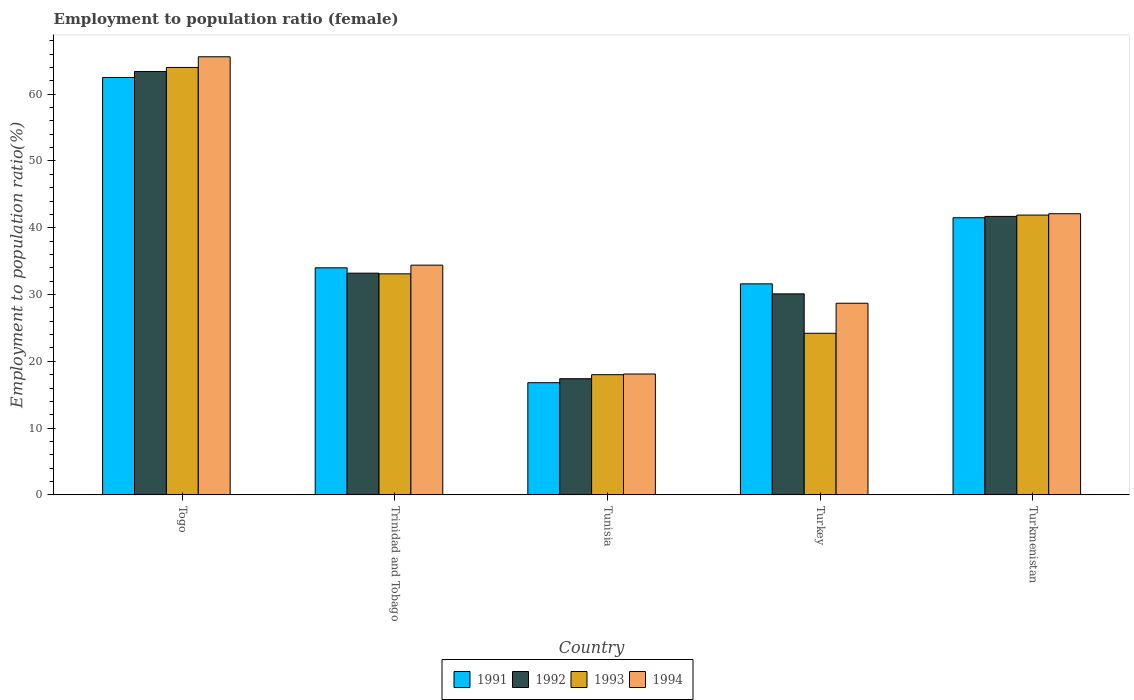Are the number of bars on each tick of the X-axis equal?
Offer a terse response. Yes. What is the label of the 1st group of bars from the left?
Provide a succinct answer. Togo. In how many cases, is the number of bars for a given country not equal to the number of legend labels?
Your response must be concise. 0. What is the employment to population ratio in 1993 in Tunisia?
Your answer should be very brief. 18. Across all countries, what is the maximum employment to population ratio in 1993?
Keep it short and to the point. 64. Across all countries, what is the minimum employment to population ratio in 1994?
Offer a very short reply. 18.1. In which country was the employment to population ratio in 1991 maximum?
Offer a terse response. Togo. In which country was the employment to population ratio in 1992 minimum?
Your answer should be compact. Tunisia. What is the total employment to population ratio in 1993 in the graph?
Keep it short and to the point. 181.2. What is the difference between the employment to population ratio in 1993 in Turkey and that in Turkmenistan?
Keep it short and to the point. -17.7. What is the difference between the employment to population ratio in 1992 in Trinidad and Tobago and the employment to population ratio in 1994 in Togo?
Your answer should be very brief. -32.4. What is the average employment to population ratio in 1992 per country?
Provide a succinct answer. 37.16. What is the difference between the employment to population ratio of/in 1994 and employment to population ratio of/in 1991 in Turkey?
Keep it short and to the point. -2.9. In how many countries, is the employment to population ratio in 1992 greater than 28 %?
Ensure brevity in your answer.  4. What is the ratio of the employment to population ratio in 1994 in Tunisia to that in Turkey?
Offer a terse response. 0.63. Is the difference between the employment to population ratio in 1994 in Trinidad and Tobago and Tunisia greater than the difference between the employment to population ratio in 1991 in Trinidad and Tobago and Tunisia?
Your response must be concise. No. What is the difference between the highest and the second highest employment to population ratio in 1994?
Make the answer very short. 23.5. What is the difference between the highest and the lowest employment to population ratio in 1991?
Provide a succinct answer. 45.7. Is it the case that in every country, the sum of the employment to population ratio in 1992 and employment to population ratio in 1994 is greater than the sum of employment to population ratio in 1991 and employment to population ratio in 1993?
Ensure brevity in your answer.  No. What does the 1st bar from the left in Trinidad and Tobago represents?
Provide a short and direct response. 1991. What does the 4th bar from the right in Togo represents?
Keep it short and to the point. 1991. Are all the bars in the graph horizontal?
Make the answer very short. No. What is the difference between two consecutive major ticks on the Y-axis?
Offer a very short reply. 10. Does the graph contain any zero values?
Your response must be concise. No. How many legend labels are there?
Offer a terse response. 4. How are the legend labels stacked?
Provide a short and direct response. Horizontal. What is the title of the graph?
Offer a very short reply. Employment to population ratio (female). What is the label or title of the X-axis?
Your answer should be compact. Country. What is the label or title of the Y-axis?
Your answer should be very brief. Employment to population ratio(%). What is the Employment to population ratio(%) in 1991 in Togo?
Provide a succinct answer. 62.5. What is the Employment to population ratio(%) in 1992 in Togo?
Offer a very short reply. 63.4. What is the Employment to population ratio(%) of 1994 in Togo?
Keep it short and to the point. 65.6. What is the Employment to population ratio(%) of 1991 in Trinidad and Tobago?
Provide a short and direct response. 34. What is the Employment to population ratio(%) of 1992 in Trinidad and Tobago?
Your answer should be compact. 33.2. What is the Employment to population ratio(%) in 1993 in Trinidad and Tobago?
Your answer should be compact. 33.1. What is the Employment to population ratio(%) in 1994 in Trinidad and Tobago?
Give a very brief answer. 34.4. What is the Employment to population ratio(%) in 1991 in Tunisia?
Provide a succinct answer. 16.8. What is the Employment to population ratio(%) of 1992 in Tunisia?
Keep it short and to the point. 17.4. What is the Employment to population ratio(%) of 1993 in Tunisia?
Provide a succinct answer. 18. What is the Employment to population ratio(%) in 1994 in Tunisia?
Give a very brief answer. 18.1. What is the Employment to population ratio(%) in 1991 in Turkey?
Provide a short and direct response. 31.6. What is the Employment to population ratio(%) of 1992 in Turkey?
Offer a terse response. 30.1. What is the Employment to population ratio(%) in 1993 in Turkey?
Ensure brevity in your answer.  24.2. What is the Employment to population ratio(%) of 1994 in Turkey?
Offer a very short reply. 28.7. What is the Employment to population ratio(%) in 1991 in Turkmenistan?
Ensure brevity in your answer.  41.5. What is the Employment to population ratio(%) in 1992 in Turkmenistan?
Provide a short and direct response. 41.7. What is the Employment to population ratio(%) of 1993 in Turkmenistan?
Offer a very short reply. 41.9. What is the Employment to population ratio(%) of 1994 in Turkmenistan?
Keep it short and to the point. 42.1. Across all countries, what is the maximum Employment to population ratio(%) in 1991?
Your response must be concise. 62.5. Across all countries, what is the maximum Employment to population ratio(%) of 1992?
Your answer should be very brief. 63.4. Across all countries, what is the maximum Employment to population ratio(%) of 1993?
Make the answer very short. 64. Across all countries, what is the maximum Employment to population ratio(%) of 1994?
Provide a succinct answer. 65.6. Across all countries, what is the minimum Employment to population ratio(%) of 1991?
Give a very brief answer. 16.8. Across all countries, what is the minimum Employment to population ratio(%) in 1992?
Offer a terse response. 17.4. Across all countries, what is the minimum Employment to population ratio(%) of 1993?
Make the answer very short. 18. Across all countries, what is the minimum Employment to population ratio(%) in 1994?
Your response must be concise. 18.1. What is the total Employment to population ratio(%) of 1991 in the graph?
Offer a terse response. 186.4. What is the total Employment to population ratio(%) in 1992 in the graph?
Your answer should be very brief. 185.8. What is the total Employment to population ratio(%) of 1993 in the graph?
Make the answer very short. 181.2. What is the total Employment to population ratio(%) in 1994 in the graph?
Offer a very short reply. 188.9. What is the difference between the Employment to population ratio(%) of 1992 in Togo and that in Trinidad and Tobago?
Ensure brevity in your answer.  30.2. What is the difference between the Employment to population ratio(%) of 1993 in Togo and that in Trinidad and Tobago?
Make the answer very short. 30.9. What is the difference between the Employment to population ratio(%) in 1994 in Togo and that in Trinidad and Tobago?
Keep it short and to the point. 31.2. What is the difference between the Employment to population ratio(%) of 1991 in Togo and that in Tunisia?
Keep it short and to the point. 45.7. What is the difference between the Employment to population ratio(%) of 1994 in Togo and that in Tunisia?
Offer a very short reply. 47.5. What is the difference between the Employment to population ratio(%) in 1991 in Togo and that in Turkey?
Keep it short and to the point. 30.9. What is the difference between the Employment to population ratio(%) of 1992 in Togo and that in Turkey?
Your answer should be very brief. 33.3. What is the difference between the Employment to population ratio(%) of 1993 in Togo and that in Turkey?
Make the answer very short. 39.8. What is the difference between the Employment to population ratio(%) of 1994 in Togo and that in Turkey?
Make the answer very short. 36.9. What is the difference between the Employment to population ratio(%) in 1992 in Togo and that in Turkmenistan?
Provide a short and direct response. 21.7. What is the difference between the Employment to population ratio(%) in 1993 in Togo and that in Turkmenistan?
Provide a succinct answer. 22.1. What is the difference between the Employment to population ratio(%) of 1991 in Trinidad and Tobago and that in Tunisia?
Give a very brief answer. 17.2. What is the difference between the Employment to population ratio(%) in 1992 in Trinidad and Tobago and that in Tunisia?
Provide a short and direct response. 15.8. What is the difference between the Employment to population ratio(%) in 1993 in Trinidad and Tobago and that in Tunisia?
Provide a succinct answer. 15.1. What is the difference between the Employment to population ratio(%) of 1994 in Trinidad and Tobago and that in Tunisia?
Provide a short and direct response. 16.3. What is the difference between the Employment to population ratio(%) of 1993 in Trinidad and Tobago and that in Turkey?
Your answer should be compact. 8.9. What is the difference between the Employment to population ratio(%) in 1992 in Trinidad and Tobago and that in Turkmenistan?
Provide a short and direct response. -8.5. What is the difference between the Employment to population ratio(%) in 1994 in Trinidad and Tobago and that in Turkmenistan?
Your response must be concise. -7.7. What is the difference between the Employment to population ratio(%) of 1991 in Tunisia and that in Turkey?
Make the answer very short. -14.8. What is the difference between the Employment to population ratio(%) in 1993 in Tunisia and that in Turkey?
Give a very brief answer. -6.2. What is the difference between the Employment to population ratio(%) of 1991 in Tunisia and that in Turkmenistan?
Ensure brevity in your answer.  -24.7. What is the difference between the Employment to population ratio(%) of 1992 in Tunisia and that in Turkmenistan?
Provide a short and direct response. -24.3. What is the difference between the Employment to population ratio(%) of 1993 in Tunisia and that in Turkmenistan?
Make the answer very short. -23.9. What is the difference between the Employment to population ratio(%) of 1992 in Turkey and that in Turkmenistan?
Keep it short and to the point. -11.6. What is the difference between the Employment to population ratio(%) in 1993 in Turkey and that in Turkmenistan?
Ensure brevity in your answer.  -17.7. What is the difference between the Employment to population ratio(%) of 1994 in Turkey and that in Turkmenistan?
Your answer should be very brief. -13.4. What is the difference between the Employment to population ratio(%) in 1991 in Togo and the Employment to population ratio(%) in 1992 in Trinidad and Tobago?
Your response must be concise. 29.3. What is the difference between the Employment to population ratio(%) of 1991 in Togo and the Employment to population ratio(%) of 1993 in Trinidad and Tobago?
Provide a short and direct response. 29.4. What is the difference between the Employment to population ratio(%) of 1991 in Togo and the Employment to population ratio(%) of 1994 in Trinidad and Tobago?
Provide a succinct answer. 28.1. What is the difference between the Employment to population ratio(%) of 1992 in Togo and the Employment to population ratio(%) of 1993 in Trinidad and Tobago?
Provide a short and direct response. 30.3. What is the difference between the Employment to population ratio(%) of 1992 in Togo and the Employment to population ratio(%) of 1994 in Trinidad and Tobago?
Offer a terse response. 29. What is the difference between the Employment to population ratio(%) of 1993 in Togo and the Employment to population ratio(%) of 1994 in Trinidad and Tobago?
Offer a very short reply. 29.6. What is the difference between the Employment to population ratio(%) in 1991 in Togo and the Employment to population ratio(%) in 1992 in Tunisia?
Ensure brevity in your answer.  45.1. What is the difference between the Employment to population ratio(%) in 1991 in Togo and the Employment to population ratio(%) in 1993 in Tunisia?
Provide a short and direct response. 44.5. What is the difference between the Employment to population ratio(%) in 1991 in Togo and the Employment to population ratio(%) in 1994 in Tunisia?
Offer a very short reply. 44.4. What is the difference between the Employment to population ratio(%) in 1992 in Togo and the Employment to population ratio(%) in 1993 in Tunisia?
Your answer should be compact. 45.4. What is the difference between the Employment to population ratio(%) in 1992 in Togo and the Employment to population ratio(%) in 1994 in Tunisia?
Your answer should be very brief. 45.3. What is the difference between the Employment to population ratio(%) in 1993 in Togo and the Employment to population ratio(%) in 1994 in Tunisia?
Keep it short and to the point. 45.9. What is the difference between the Employment to population ratio(%) of 1991 in Togo and the Employment to population ratio(%) of 1992 in Turkey?
Provide a short and direct response. 32.4. What is the difference between the Employment to population ratio(%) in 1991 in Togo and the Employment to population ratio(%) in 1993 in Turkey?
Keep it short and to the point. 38.3. What is the difference between the Employment to population ratio(%) of 1991 in Togo and the Employment to population ratio(%) of 1994 in Turkey?
Make the answer very short. 33.8. What is the difference between the Employment to population ratio(%) of 1992 in Togo and the Employment to population ratio(%) of 1993 in Turkey?
Provide a short and direct response. 39.2. What is the difference between the Employment to population ratio(%) of 1992 in Togo and the Employment to population ratio(%) of 1994 in Turkey?
Your answer should be compact. 34.7. What is the difference between the Employment to population ratio(%) of 1993 in Togo and the Employment to population ratio(%) of 1994 in Turkey?
Your answer should be very brief. 35.3. What is the difference between the Employment to population ratio(%) of 1991 in Togo and the Employment to population ratio(%) of 1992 in Turkmenistan?
Keep it short and to the point. 20.8. What is the difference between the Employment to population ratio(%) in 1991 in Togo and the Employment to population ratio(%) in 1993 in Turkmenistan?
Provide a short and direct response. 20.6. What is the difference between the Employment to population ratio(%) of 1991 in Togo and the Employment to population ratio(%) of 1994 in Turkmenistan?
Your answer should be very brief. 20.4. What is the difference between the Employment to population ratio(%) of 1992 in Togo and the Employment to population ratio(%) of 1993 in Turkmenistan?
Give a very brief answer. 21.5. What is the difference between the Employment to population ratio(%) in 1992 in Togo and the Employment to population ratio(%) in 1994 in Turkmenistan?
Give a very brief answer. 21.3. What is the difference between the Employment to population ratio(%) in 1993 in Togo and the Employment to population ratio(%) in 1994 in Turkmenistan?
Ensure brevity in your answer.  21.9. What is the difference between the Employment to population ratio(%) of 1991 in Trinidad and Tobago and the Employment to population ratio(%) of 1993 in Tunisia?
Your answer should be compact. 16. What is the difference between the Employment to population ratio(%) of 1991 in Trinidad and Tobago and the Employment to population ratio(%) of 1994 in Tunisia?
Give a very brief answer. 15.9. What is the difference between the Employment to population ratio(%) of 1992 in Trinidad and Tobago and the Employment to population ratio(%) of 1993 in Tunisia?
Your answer should be very brief. 15.2. What is the difference between the Employment to population ratio(%) in 1993 in Trinidad and Tobago and the Employment to population ratio(%) in 1994 in Tunisia?
Make the answer very short. 15. What is the difference between the Employment to population ratio(%) in 1991 in Trinidad and Tobago and the Employment to population ratio(%) in 1993 in Turkey?
Provide a short and direct response. 9.8. What is the difference between the Employment to population ratio(%) in 1991 in Trinidad and Tobago and the Employment to population ratio(%) in 1994 in Turkey?
Your answer should be compact. 5.3. What is the difference between the Employment to population ratio(%) in 1992 in Trinidad and Tobago and the Employment to population ratio(%) in 1993 in Turkey?
Your answer should be compact. 9. What is the difference between the Employment to population ratio(%) of 1993 in Trinidad and Tobago and the Employment to population ratio(%) of 1994 in Turkey?
Offer a very short reply. 4.4. What is the difference between the Employment to population ratio(%) in 1991 in Trinidad and Tobago and the Employment to population ratio(%) in 1992 in Turkmenistan?
Make the answer very short. -7.7. What is the difference between the Employment to population ratio(%) in 1991 in Trinidad and Tobago and the Employment to population ratio(%) in 1993 in Turkmenistan?
Your answer should be compact. -7.9. What is the difference between the Employment to population ratio(%) of 1991 in Tunisia and the Employment to population ratio(%) of 1993 in Turkey?
Your response must be concise. -7.4. What is the difference between the Employment to population ratio(%) in 1992 in Tunisia and the Employment to population ratio(%) in 1993 in Turkey?
Your answer should be very brief. -6.8. What is the difference between the Employment to population ratio(%) of 1991 in Tunisia and the Employment to population ratio(%) of 1992 in Turkmenistan?
Provide a succinct answer. -24.9. What is the difference between the Employment to population ratio(%) in 1991 in Tunisia and the Employment to population ratio(%) in 1993 in Turkmenistan?
Make the answer very short. -25.1. What is the difference between the Employment to population ratio(%) in 1991 in Tunisia and the Employment to population ratio(%) in 1994 in Turkmenistan?
Give a very brief answer. -25.3. What is the difference between the Employment to population ratio(%) of 1992 in Tunisia and the Employment to population ratio(%) of 1993 in Turkmenistan?
Your response must be concise. -24.5. What is the difference between the Employment to population ratio(%) of 1992 in Tunisia and the Employment to population ratio(%) of 1994 in Turkmenistan?
Your answer should be compact. -24.7. What is the difference between the Employment to population ratio(%) of 1993 in Tunisia and the Employment to population ratio(%) of 1994 in Turkmenistan?
Provide a succinct answer. -24.1. What is the difference between the Employment to population ratio(%) of 1991 in Turkey and the Employment to population ratio(%) of 1993 in Turkmenistan?
Offer a very short reply. -10.3. What is the difference between the Employment to population ratio(%) of 1992 in Turkey and the Employment to population ratio(%) of 1993 in Turkmenistan?
Ensure brevity in your answer.  -11.8. What is the difference between the Employment to population ratio(%) of 1993 in Turkey and the Employment to population ratio(%) of 1994 in Turkmenistan?
Keep it short and to the point. -17.9. What is the average Employment to population ratio(%) of 1991 per country?
Give a very brief answer. 37.28. What is the average Employment to population ratio(%) in 1992 per country?
Your answer should be compact. 37.16. What is the average Employment to population ratio(%) in 1993 per country?
Your answer should be very brief. 36.24. What is the average Employment to population ratio(%) in 1994 per country?
Offer a very short reply. 37.78. What is the difference between the Employment to population ratio(%) in 1992 and Employment to population ratio(%) in 1994 in Togo?
Your answer should be compact. -2.2. What is the difference between the Employment to population ratio(%) in 1993 and Employment to population ratio(%) in 1994 in Togo?
Keep it short and to the point. -1.6. What is the difference between the Employment to population ratio(%) of 1991 and Employment to population ratio(%) of 1994 in Trinidad and Tobago?
Make the answer very short. -0.4. What is the difference between the Employment to population ratio(%) of 1992 and Employment to population ratio(%) of 1993 in Trinidad and Tobago?
Your response must be concise. 0.1. What is the difference between the Employment to population ratio(%) in 1991 and Employment to population ratio(%) in 1993 in Tunisia?
Your answer should be very brief. -1.2. What is the difference between the Employment to population ratio(%) in 1991 and Employment to population ratio(%) in 1994 in Tunisia?
Provide a short and direct response. -1.3. What is the difference between the Employment to population ratio(%) of 1992 and Employment to population ratio(%) of 1994 in Tunisia?
Your response must be concise. -0.7. What is the difference between the Employment to population ratio(%) in 1991 and Employment to population ratio(%) in 1992 in Turkey?
Provide a short and direct response. 1.5. What is the difference between the Employment to population ratio(%) of 1991 and Employment to population ratio(%) of 1993 in Turkey?
Your answer should be compact. 7.4. What is the difference between the Employment to population ratio(%) in 1993 and Employment to population ratio(%) in 1994 in Turkey?
Make the answer very short. -4.5. What is the difference between the Employment to population ratio(%) of 1991 and Employment to population ratio(%) of 1992 in Turkmenistan?
Your answer should be very brief. -0.2. What is the difference between the Employment to population ratio(%) in 1991 and Employment to population ratio(%) in 1994 in Turkmenistan?
Provide a short and direct response. -0.6. What is the difference between the Employment to population ratio(%) in 1992 and Employment to population ratio(%) in 1993 in Turkmenistan?
Provide a short and direct response. -0.2. What is the difference between the Employment to population ratio(%) in 1992 and Employment to population ratio(%) in 1994 in Turkmenistan?
Ensure brevity in your answer.  -0.4. What is the difference between the Employment to population ratio(%) of 1993 and Employment to population ratio(%) of 1994 in Turkmenistan?
Offer a terse response. -0.2. What is the ratio of the Employment to population ratio(%) in 1991 in Togo to that in Trinidad and Tobago?
Offer a very short reply. 1.84. What is the ratio of the Employment to population ratio(%) of 1992 in Togo to that in Trinidad and Tobago?
Give a very brief answer. 1.91. What is the ratio of the Employment to population ratio(%) of 1993 in Togo to that in Trinidad and Tobago?
Give a very brief answer. 1.93. What is the ratio of the Employment to population ratio(%) of 1994 in Togo to that in Trinidad and Tobago?
Offer a very short reply. 1.91. What is the ratio of the Employment to population ratio(%) in 1991 in Togo to that in Tunisia?
Offer a terse response. 3.72. What is the ratio of the Employment to population ratio(%) in 1992 in Togo to that in Tunisia?
Your answer should be very brief. 3.64. What is the ratio of the Employment to population ratio(%) in 1993 in Togo to that in Tunisia?
Keep it short and to the point. 3.56. What is the ratio of the Employment to population ratio(%) in 1994 in Togo to that in Tunisia?
Your answer should be compact. 3.62. What is the ratio of the Employment to population ratio(%) in 1991 in Togo to that in Turkey?
Your answer should be compact. 1.98. What is the ratio of the Employment to population ratio(%) in 1992 in Togo to that in Turkey?
Make the answer very short. 2.11. What is the ratio of the Employment to population ratio(%) in 1993 in Togo to that in Turkey?
Offer a very short reply. 2.64. What is the ratio of the Employment to population ratio(%) in 1994 in Togo to that in Turkey?
Your answer should be very brief. 2.29. What is the ratio of the Employment to population ratio(%) in 1991 in Togo to that in Turkmenistan?
Your answer should be very brief. 1.51. What is the ratio of the Employment to population ratio(%) in 1992 in Togo to that in Turkmenistan?
Provide a succinct answer. 1.52. What is the ratio of the Employment to population ratio(%) of 1993 in Togo to that in Turkmenistan?
Provide a succinct answer. 1.53. What is the ratio of the Employment to population ratio(%) in 1994 in Togo to that in Turkmenistan?
Offer a very short reply. 1.56. What is the ratio of the Employment to population ratio(%) in 1991 in Trinidad and Tobago to that in Tunisia?
Ensure brevity in your answer.  2.02. What is the ratio of the Employment to population ratio(%) in 1992 in Trinidad and Tobago to that in Tunisia?
Offer a very short reply. 1.91. What is the ratio of the Employment to population ratio(%) of 1993 in Trinidad and Tobago to that in Tunisia?
Give a very brief answer. 1.84. What is the ratio of the Employment to population ratio(%) in 1994 in Trinidad and Tobago to that in Tunisia?
Make the answer very short. 1.9. What is the ratio of the Employment to population ratio(%) of 1991 in Trinidad and Tobago to that in Turkey?
Offer a very short reply. 1.08. What is the ratio of the Employment to population ratio(%) of 1992 in Trinidad and Tobago to that in Turkey?
Your answer should be very brief. 1.1. What is the ratio of the Employment to population ratio(%) of 1993 in Trinidad and Tobago to that in Turkey?
Make the answer very short. 1.37. What is the ratio of the Employment to population ratio(%) of 1994 in Trinidad and Tobago to that in Turkey?
Make the answer very short. 1.2. What is the ratio of the Employment to population ratio(%) of 1991 in Trinidad and Tobago to that in Turkmenistan?
Keep it short and to the point. 0.82. What is the ratio of the Employment to population ratio(%) of 1992 in Trinidad and Tobago to that in Turkmenistan?
Your response must be concise. 0.8. What is the ratio of the Employment to population ratio(%) in 1993 in Trinidad and Tobago to that in Turkmenistan?
Your response must be concise. 0.79. What is the ratio of the Employment to population ratio(%) in 1994 in Trinidad and Tobago to that in Turkmenistan?
Your answer should be very brief. 0.82. What is the ratio of the Employment to population ratio(%) in 1991 in Tunisia to that in Turkey?
Give a very brief answer. 0.53. What is the ratio of the Employment to population ratio(%) of 1992 in Tunisia to that in Turkey?
Keep it short and to the point. 0.58. What is the ratio of the Employment to population ratio(%) in 1993 in Tunisia to that in Turkey?
Ensure brevity in your answer.  0.74. What is the ratio of the Employment to population ratio(%) in 1994 in Tunisia to that in Turkey?
Provide a short and direct response. 0.63. What is the ratio of the Employment to population ratio(%) of 1991 in Tunisia to that in Turkmenistan?
Keep it short and to the point. 0.4. What is the ratio of the Employment to population ratio(%) in 1992 in Tunisia to that in Turkmenistan?
Make the answer very short. 0.42. What is the ratio of the Employment to population ratio(%) of 1993 in Tunisia to that in Turkmenistan?
Your response must be concise. 0.43. What is the ratio of the Employment to population ratio(%) in 1994 in Tunisia to that in Turkmenistan?
Your answer should be compact. 0.43. What is the ratio of the Employment to population ratio(%) of 1991 in Turkey to that in Turkmenistan?
Offer a very short reply. 0.76. What is the ratio of the Employment to population ratio(%) in 1992 in Turkey to that in Turkmenistan?
Make the answer very short. 0.72. What is the ratio of the Employment to population ratio(%) of 1993 in Turkey to that in Turkmenistan?
Your answer should be compact. 0.58. What is the ratio of the Employment to population ratio(%) of 1994 in Turkey to that in Turkmenistan?
Ensure brevity in your answer.  0.68. What is the difference between the highest and the second highest Employment to population ratio(%) in 1991?
Ensure brevity in your answer.  21. What is the difference between the highest and the second highest Employment to population ratio(%) in 1992?
Ensure brevity in your answer.  21.7. What is the difference between the highest and the second highest Employment to population ratio(%) in 1993?
Provide a short and direct response. 22.1. What is the difference between the highest and the second highest Employment to population ratio(%) in 1994?
Your response must be concise. 23.5. What is the difference between the highest and the lowest Employment to population ratio(%) of 1991?
Provide a succinct answer. 45.7. What is the difference between the highest and the lowest Employment to population ratio(%) of 1993?
Give a very brief answer. 46. What is the difference between the highest and the lowest Employment to population ratio(%) of 1994?
Provide a succinct answer. 47.5. 